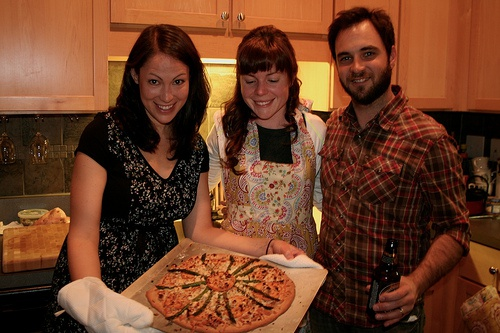Describe the objects in this image and their specific colors. I can see people in brown, black, and maroon tones, people in brown, black, and maroon tones, people in brown, black, and maroon tones, pizza in brown, maroon, and red tones, and bottle in brown, black, maroon, and gray tones in this image. 